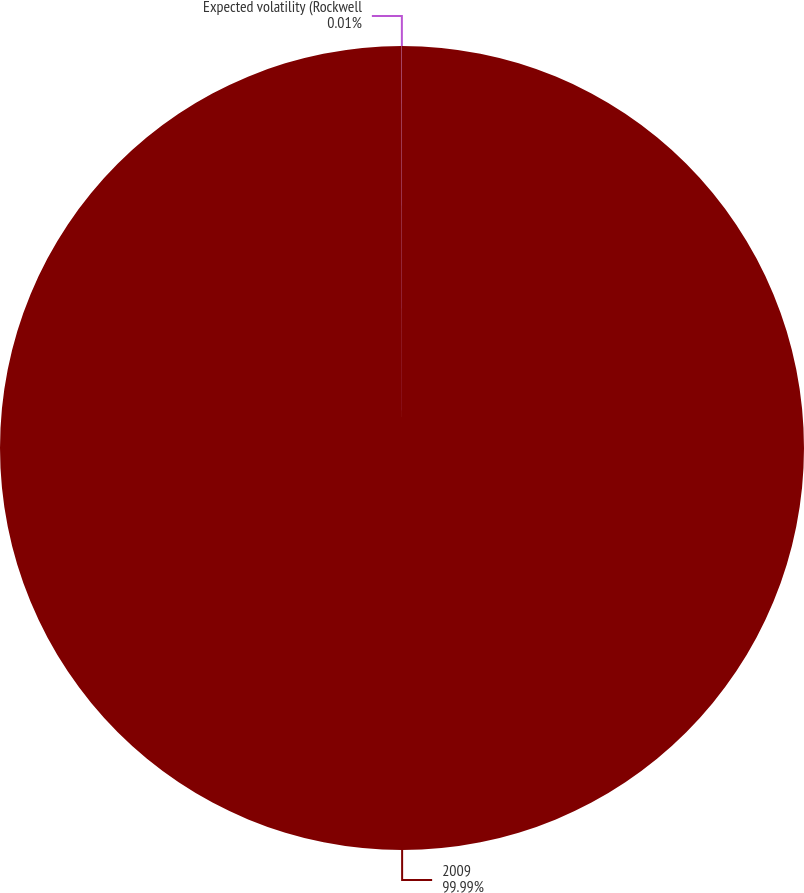<chart> <loc_0><loc_0><loc_500><loc_500><pie_chart><fcel>2009<fcel>Expected volatility (Rockwell<nl><fcel>99.99%<fcel>0.01%<nl></chart> 